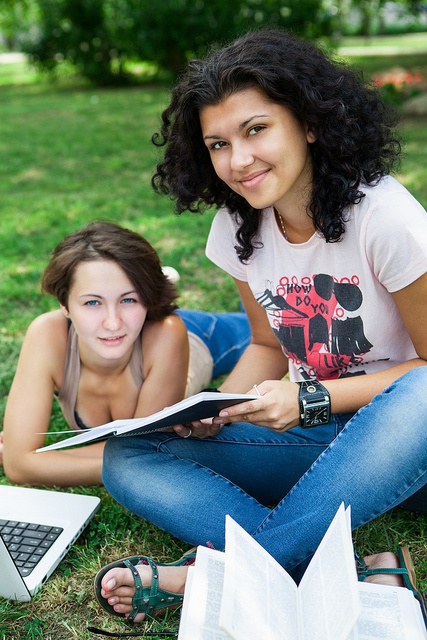Describe the objects in this image and their specific colors. I can see people in darkgreen, black, lightgray, teal, and gray tones, people in darkgreen, tan, and gray tones, book in darkgreen, white, blue, and black tones, laptop in darkgreen, white, darkgray, lightblue, and gray tones, and book in darkgreen, lavender, darkgray, and black tones in this image. 